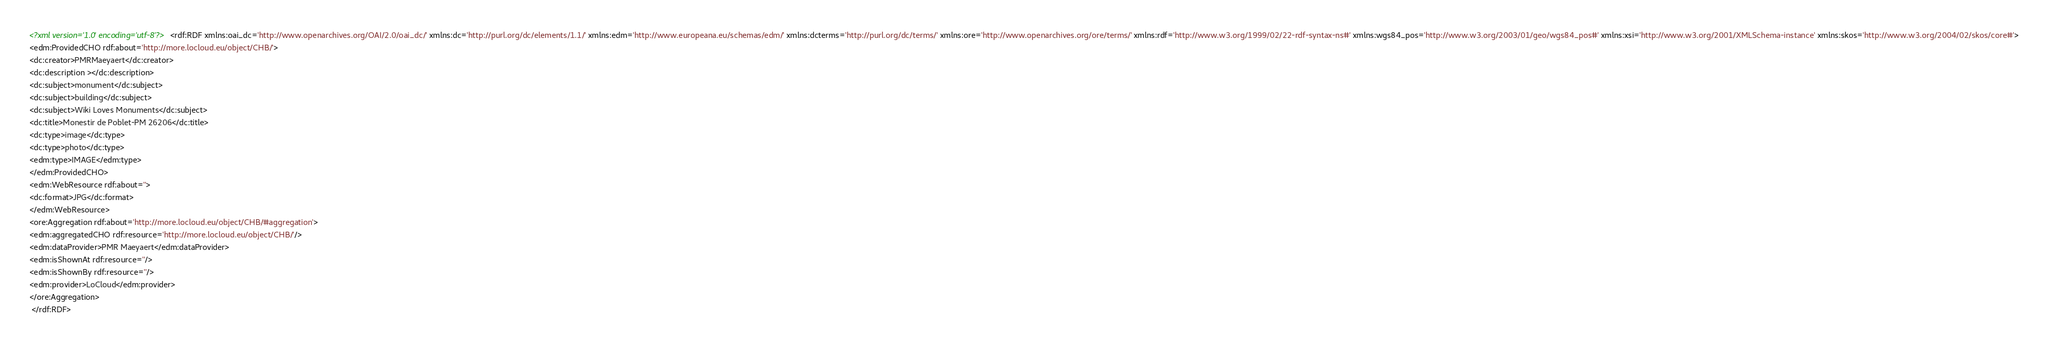Convert code to text. <code><loc_0><loc_0><loc_500><loc_500><_XML_><?xml version='1.0' encoding='utf-8'?><rdf:RDF xmlns:oai_dc='http://www.openarchives.org/OAI/2.0/oai_dc/' xmlns:dc='http://purl.org/dc/elements/1.1/' xmlns:edm='http://www.europeana.eu/schemas/edm/' xmlns:dcterms='http://purl.org/dc/terms/' xmlns:ore='http://www.openarchives.org/ore/terms/' xmlns:rdf='http://www.w3.org/1999/02/22-rdf-syntax-ns#' xmlns:wgs84_pos='http://www.w3.org/2003/01/geo/wgs84_pos#' xmlns:xsi='http://www.w3.org/2001/XMLSchema-instance' xmlns:skos='http://www.w3.org/2004/02/skos/core#'>
<edm:ProvidedCHO rdf:about='http://more.locloud.eu/object/CHB/'>
<dc:creator>PMRMaeyaert</dc:creator>
<dc:description ></dc:description>
<dc:subject>monument</dc:subject>
<dc:subject>building</dc:subject>
<dc:subject>Wiki Loves Monuments</dc:subject>
<dc:title>Monestir de Poblet-PM 26206</dc:title>
<dc:type>image</dc:type>
<dc:type>photo</dc:type>
<edm:type>IMAGE</edm:type>
</edm:ProvidedCHO>
<edm:WebResource rdf:about=''>
<dc:format>JPG</dc:format>
</edm:WebResource>
<ore:Aggregation rdf:about='http://more.locloud.eu/object/CHB/#aggregation'>
<edm:aggregatedCHO rdf:resource='http://more.locloud.eu/object/CHB/'/>
<edm:dataProvider>PMR Maeyaert</edm:dataProvider>
<edm:isShownAt rdf:resource=''/>
<edm:isShownBy rdf:resource=''/>
<edm:provider>LoCloud</edm:provider>
</ore:Aggregation>
 </rdf:RDF>
</code> 